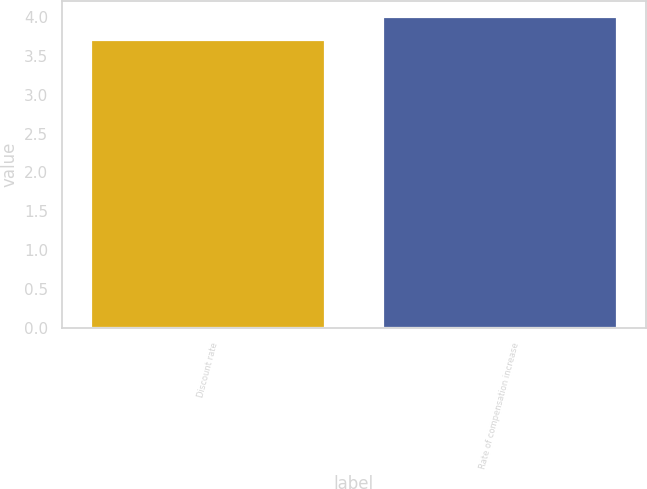Convert chart to OTSL. <chart><loc_0><loc_0><loc_500><loc_500><bar_chart><fcel>Discount rate<fcel>Rate of compensation increase<nl><fcel>3.7<fcel>4<nl></chart> 